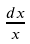Convert formula to latex. <formula><loc_0><loc_0><loc_500><loc_500>\frac { d x } { x }</formula> 